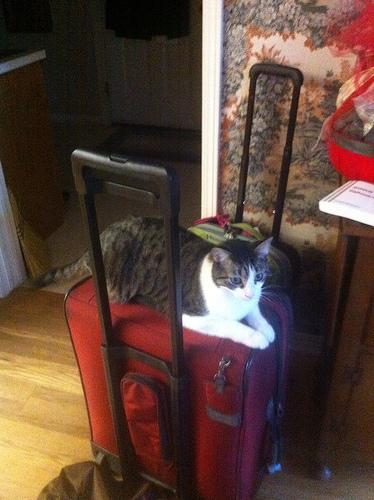What animal is the main focus of the image, and what is its position? The main focus is a tabby cat, which is contently sitting on a red suitcase. Is there any furniture visible in the room? If so, describe it. There is a wooden cabinet and an antique table visible in the room. Can you identify any object that may belong to the cat? There is no specific object identifiable as belonging to the cat. Describe the scene suggested by the presence of suitcases. The scene suggests someone might be preparing to go on a trip. Briefly mention the cat's interaction with the suitcases. The cat is lying on the red suitcase, seemingly ready to join the trip. Identify the primary color and type of the flooring in the image. The flooring is light brown and made of wooden floorboards. What objects can you see on the table, and what is their color? On the table, there is a book, a plastic bag, and a red bowl with a red and white bow. Enumerate the visible attributes of the cat's physical appearance. The cat has white paws, a striped black and gray tail, and watchful almond-shaped eyes. Count the number of suitcases in the image and describe their colors. There are two suitcases: one is red, and the other is light green. Provide a brief description of the wall decoration. The wall has a floral wallpaper with gray and white designs, featuring flowers and shrubs. Locate the white front paws, bib, and lower face of the cat within the image. X:181 Y:233 Width:97 Height:97 What sentiment does the image of the cat on the suitcase convey? It conveys a sense of contentment and calm. Identify the color and type of the floor. The floor is wooden and light brown in color. Identify any text present in the image. There is no text visible in the image. Are there any flowers present in the image, and if so, where? Yes, there are blue flowers on the wallpaper. What is the book's position in relation to the counter? The book is sitting on the counter. Does the cat show any signs of emotions in the image? The cat appears to be content and watchful. Describe the pattern on the wallpaper. The pattern consists of blue flowers and gray and white shrubs. Evaluate the quality of the image in terms of clarity and detail. The image is clear and has a good level of detail. What lies beneath the suitcases in the image? A wooden floor lies beneath the suitcases. What is the color of the suitcases near the door? The suitcases are red and light green. Analyze the interaction between the cat and the red suitcase. The cat interacts with the red suitcase by sitting on it. Examine the image for any unusual or unexpected objects. There are no evident anomalies in the image. Does the cat have any unique markings? Yes, the cat has white paws and a striped black and gray tail. Which object in the image has a pink tag? The green suitcase has a pink tag. Describe the cat's position in relation to the suitcase. The cat is sitting on the red suitcase. Determine the attributes of the black handle on the red suitcase. The handle is telescoping and extended. Is the zipper on the red suitcase open or closed? The zipper on the red suitcase is closed. What color is the door frame? The door frame is white. 